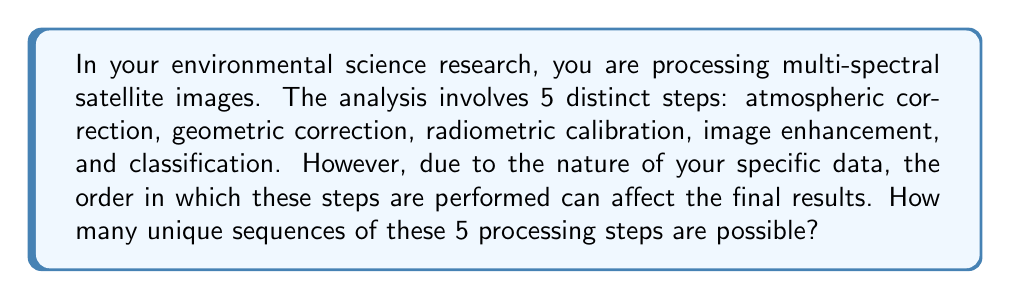Can you answer this question? To solve this problem, we need to understand that we are dealing with a permutation. We have 5 distinct steps, and we need to arrange all 5 of them in different orders. This is a perfect scenario for using the permutation formula.

The formula for permutations of n distinct objects is:

$$P(n) = n!$$

Where $n!$ represents the factorial of $n$.

In this case, $n = 5$ (the number of distinct processing steps).

So, we calculate:

$$P(5) = 5!$$

$$5! = 5 \times 4 \times 3 \times 2 \times 1 = 120$$

This means there are 120 unique ways to arrange these 5 processing steps.

To break it down further:
1. We have 5 choices for the first step
2. After choosing the first step, we have 4 choices for the second step
3. Then 3 choices for the third step
4. 2 choices for the fourth step
5. And only 1 choice left for the last step

Multiplying these together: $5 \times 4 \times 3 \times 2 \times 1 = 120$

This multiplication principle is the foundation of the factorial notation used in permutations.
Answer: There are 120 unique sequences possible for processing the multi-spectral satellite images. 